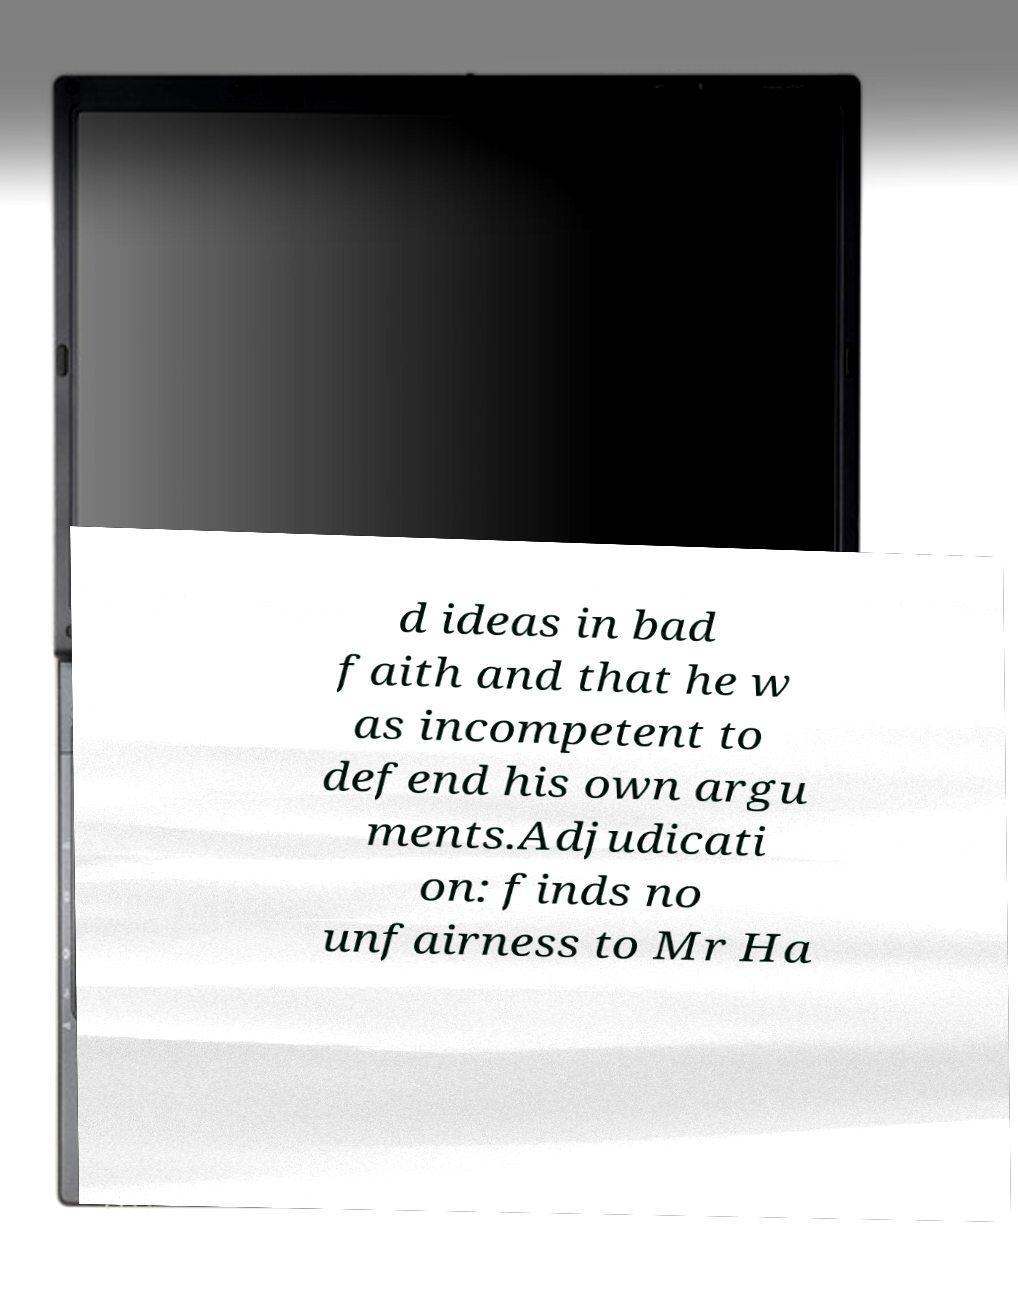There's text embedded in this image that I need extracted. Can you transcribe it verbatim? d ideas in bad faith and that he w as incompetent to defend his own argu ments.Adjudicati on: finds no unfairness to Mr Ha 